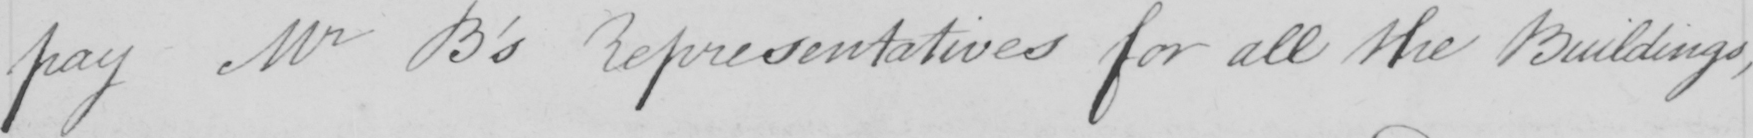What does this handwritten line say? pay Mr B ' s Representatives for all the Buildings , 